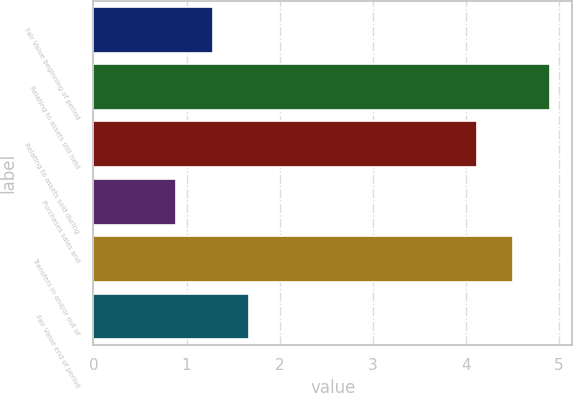Convert chart to OTSL. <chart><loc_0><loc_0><loc_500><loc_500><bar_chart><fcel>Fair Value beginning of period<fcel>Relating to assets still held<fcel>Relating to assets sold during<fcel>Purchases sales and<fcel>Transfers in and/or out of<fcel>Fair Value end of period<nl><fcel>1.28<fcel>4.9<fcel>4.12<fcel>0.89<fcel>4.51<fcel>1.67<nl></chart> 